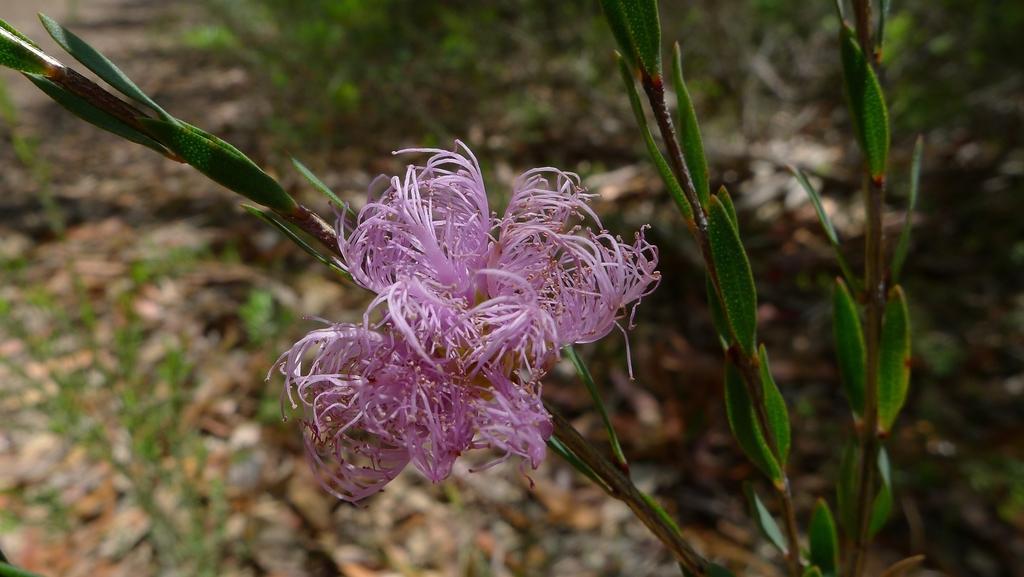Could you give a brief overview of what you see in this image? In this picture we can see a plant with a flower and in the background we can see grass on the ground. 